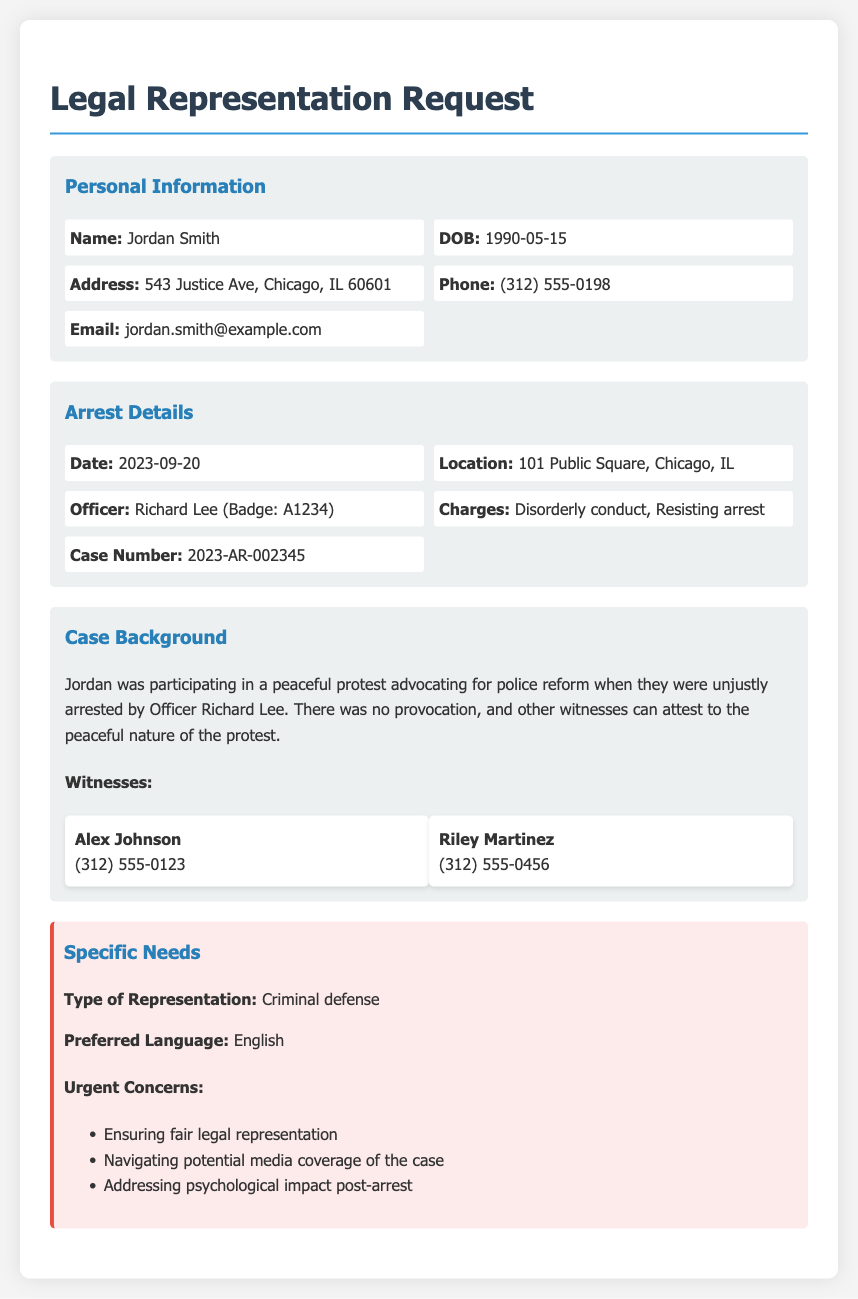What is the full name of the client? The client's name is stated in the personal information section of the document.
Answer: Jordan Smith What is the case number? The case number can be found in the arrest details section of the document.
Answer: 2023-AR-002345 What charge is mentioned in relation to the arrest? The charges are listed in the arrest details section of the document.
Answer: Disorderly conduct, Resisting arrest When did the arrest occur? The date of the arrest is given in the arrest details section.
Answer: 2023-09-20 Who was the arresting officer? The name of the arresting officer is mentioned in the arrest details section.
Answer: Richard Lee What was the location of the arrest? The location of the arrest is specified in the arrest details section.
Answer: 101 Public Square, Chicago, IL What is one of the urgent concerns mentioned in the document? The specific needs section lists several urgent concerns; one of them can be highlighted here.
Answer: Ensuring fair legal representation How many witnesses are listed in the document? The number of witnesses is indicated in the case background section, where witness names are provided.
Answer: 2 What type of legal representation is being requested? The specific needs section states the required type of representation.
Answer: Criminal defense 